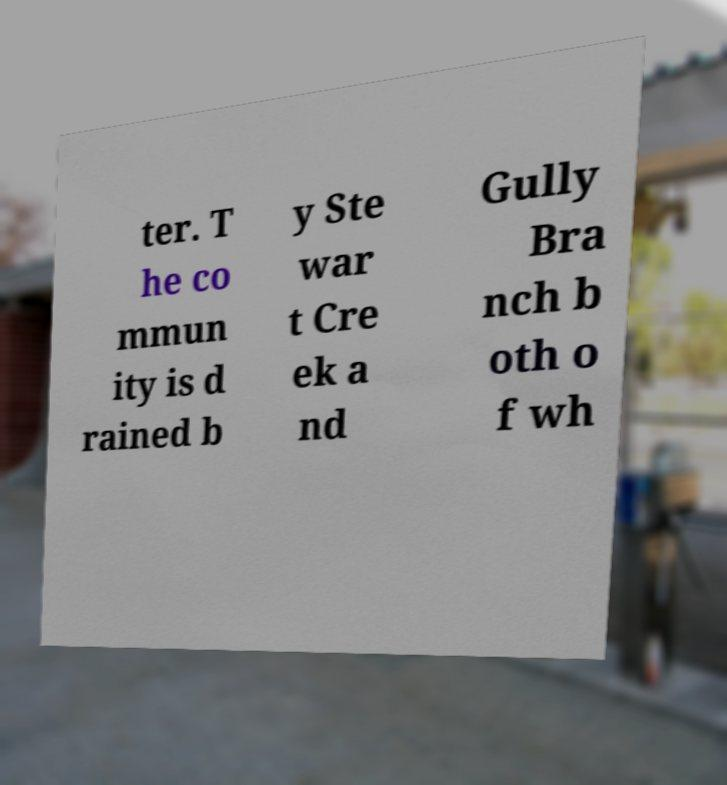Please identify and transcribe the text found in this image. ter. T he co mmun ity is d rained b y Ste war t Cre ek a nd Gully Bra nch b oth o f wh 